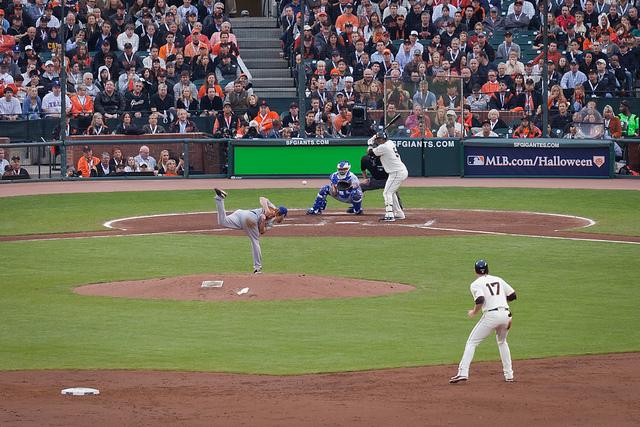Is this a pro game?
Be succinct. Yes. What was just thrown?
Be succinct. Baseball. What is the main color people are wearing in the photo?
Give a very brief answer. White. 